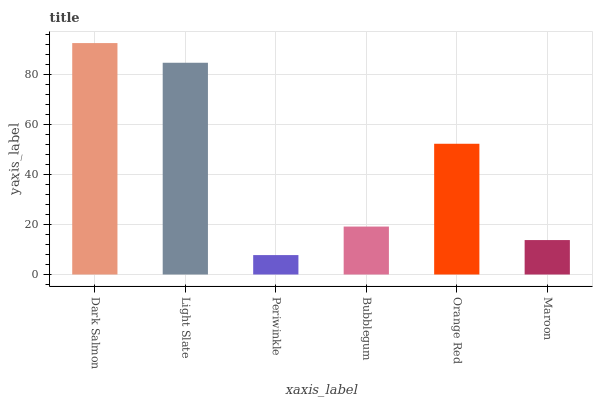Is Periwinkle the minimum?
Answer yes or no. Yes. Is Dark Salmon the maximum?
Answer yes or no. Yes. Is Light Slate the minimum?
Answer yes or no. No. Is Light Slate the maximum?
Answer yes or no. No. Is Dark Salmon greater than Light Slate?
Answer yes or no. Yes. Is Light Slate less than Dark Salmon?
Answer yes or no. Yes. Is Light Slate greater than Dark Salmon?
Answer yes or no. No. Is Dark Salmon less than Light Slate?
Answer yes or no. No. Is Orange Red the high median?
Answer yes or no. Yes. Is Bubblegum the low median?
Answer yes or no. Yes. Is Maroon the high median?
Answer yes or no. No. Is Maroon the low median?
Answer yes or no. No. 